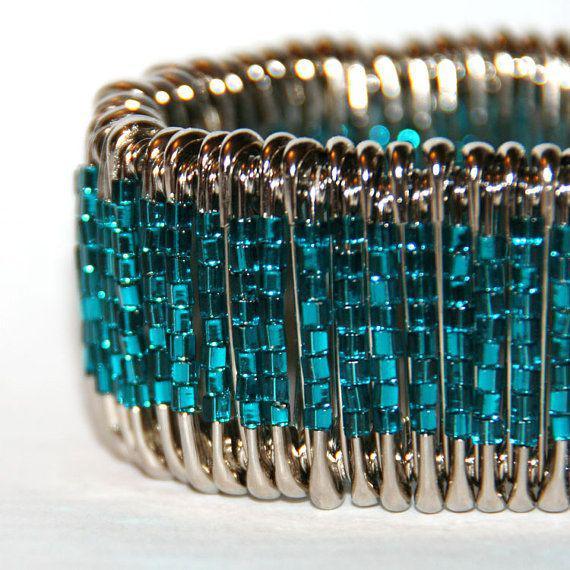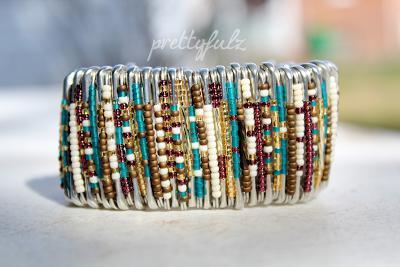The first image is the image on the left, the second image is the image on the right. Assess this claim about the two images: "One of the bracelets features small, round, rainbow colored beads including the colors pink and orange.". Correct or not? Answer yes or no. No. The first image is the image on the left, the second image is the image on the right. Considering the images on both sides, is "jewelry made from bobby pins are on human wrists" valid? Answer yes or no. No. 